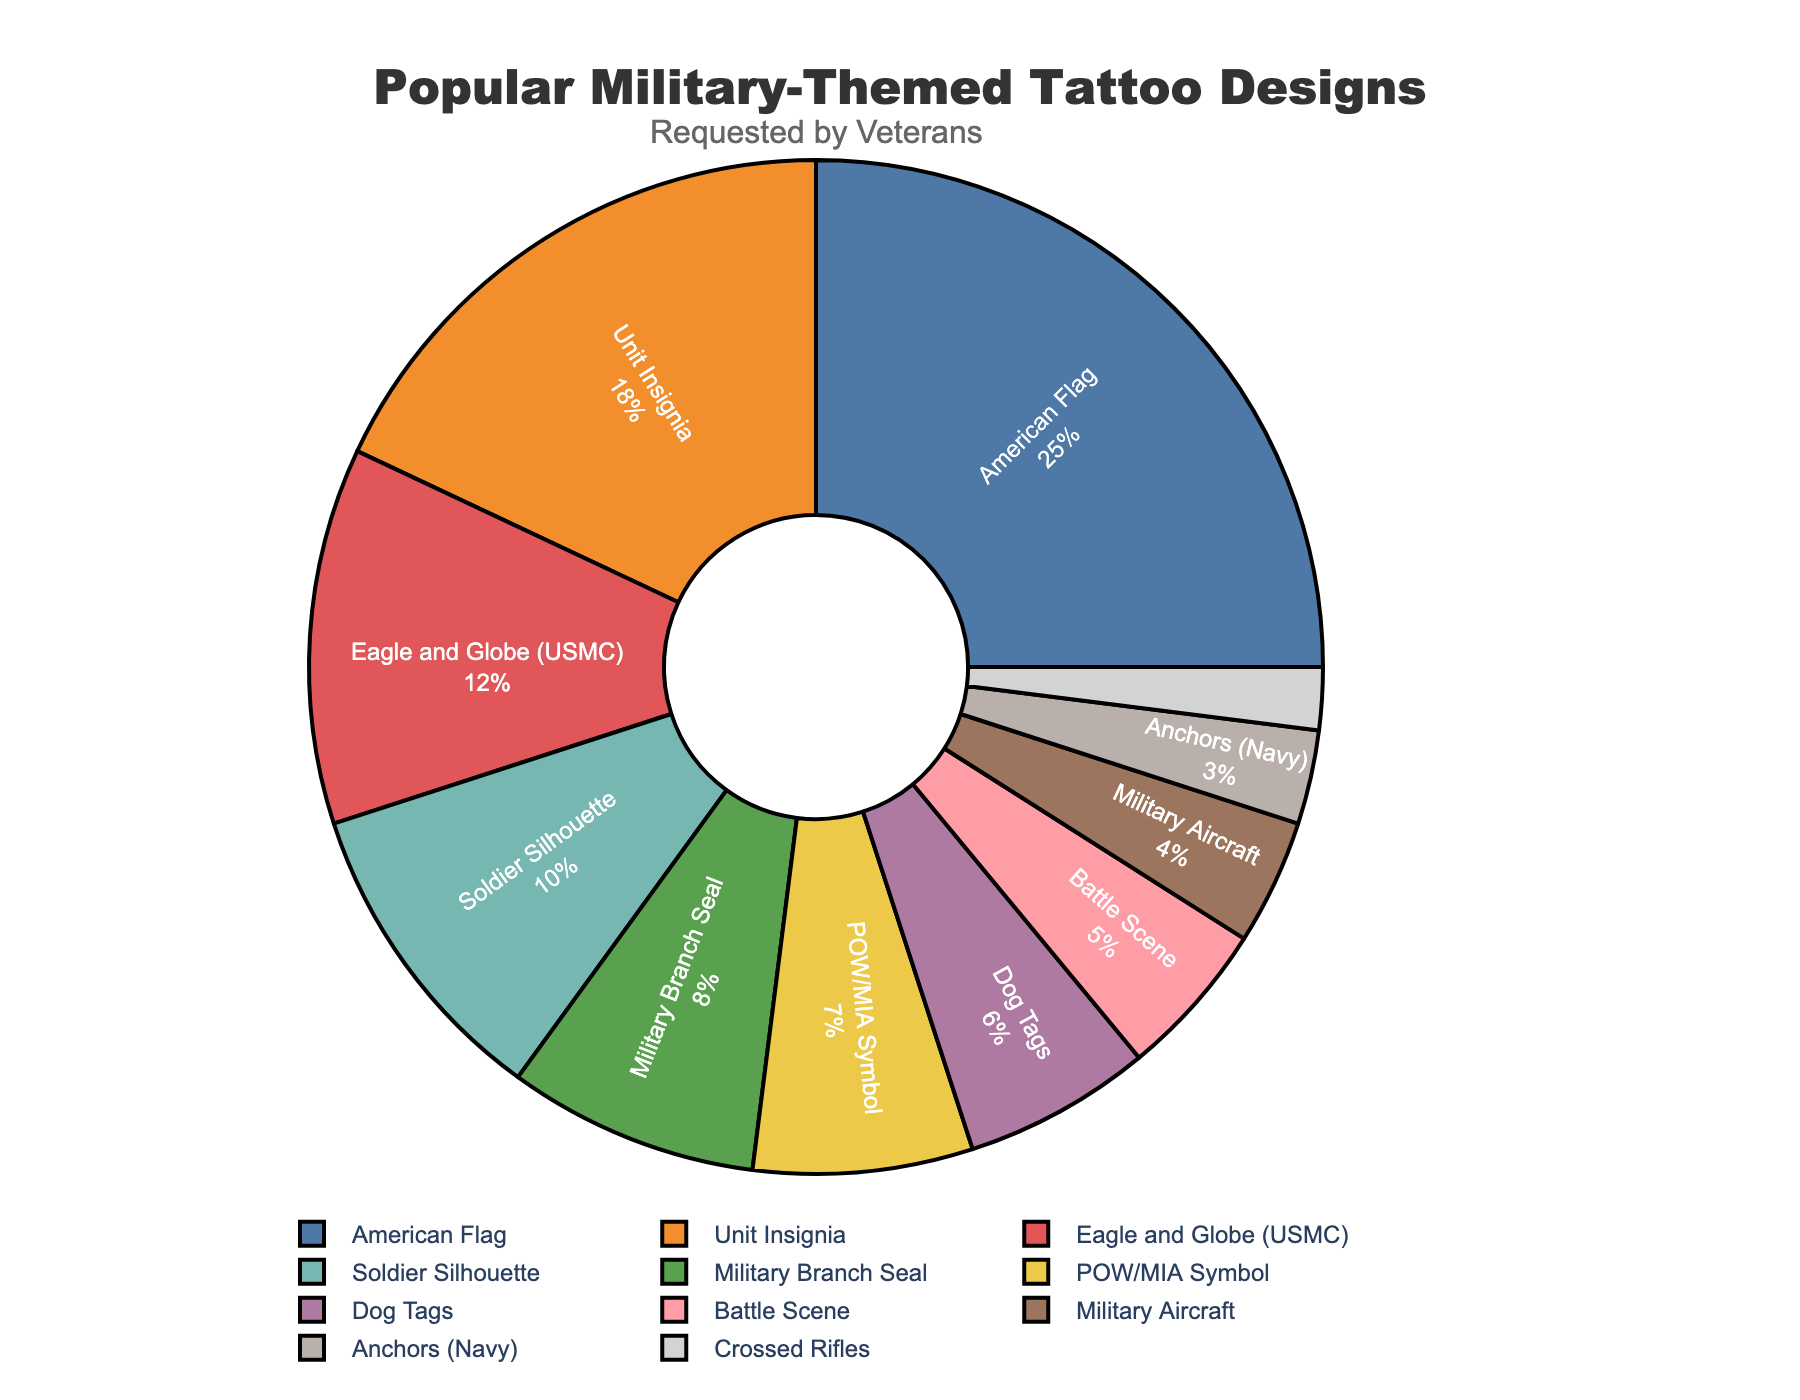What is the most popular military-themed tattoo design requested by veterans? To find the most popular design, look at the segment with the largest percentage in the pie chart. The "American Flag" segment occupies the largest portion, with 25%.
Answer: American Flag Which design is more requested, Military Branch Seal or Dog Tags? Compare the percentage values of the "Military Branch Seal" and "Dog Tags" segments. The Military Branch Seal has 8%, and Dog Tags have 6%, so Military Branch Seal is more requested.
Answer: Military Branch Seal What is the total percentage of designs related to branches of the military (Unit Insignia, Eagle and Globe (USMC), Military Branch Seal, Anchors (Navy), Crossed Rifles)? Sum the percentages for Unit Insignia (18%), Eagle and Globe (USMC) (12%), Military Branch Seal (8%), Anchors (Navy) (3%), and Crossed Rifles (2%): 18 + 12 + 8 + 3 + 2 = 43%.
Answer: 43% If you combine the percentages of Soldier Silhouette and POW/MIA Symbol designs, what percentage of the total do they make up? Add the percentages of Soldier Silhouette (10%) and POW/MIA Symbol (7%) to find the total: 10 + 7 = 17%.
Answer: 17% What portion of the pie chart does the Dog Tags design occupy visually based on its percentage? The Dog Tags design represents 6% of the pie chart. Visually, this would be a small segment of the pie chart, occupying 6% of the circular area.
Answer: 6% How does the request percentage of Battle Scene compare to Military Aircraft? Compare the proportion of Battle Scene (5%) with Military Aircraft (4%). Battle Scene has a slightly higher percentage than Military Aircraft.
Answer: Battle Scene What is the combined percentage of the three least popular designs? Identify the three designs with the smallest percentages: Crossed Rifles (2%), Anchors (Navy) (3%), and Military Aircraft (4%). Add these percentages: 2 + 3 + 4 = 9%.
Answer: 9% Among the designs with medium popularity (between 5% and 15%), which one has the lowest percentage? Focus on the range 5%-15% and identify the designs: POW/MIA Symbol (7%), Dog Tags (6%), Battle Scene (5%), Eagle and Globe (USMC) (12%), and Soldier Silhouette (10%). The Battle Scene has the lowest percentage in this range.
Answer: Battle Scene If the American Flag design's popularity increased by 5%, what would its new percentage be? Add 5% to the American Flag's current percentage of 25%: 25 + 5 = 30%.
Answer: 30% What is the ratio of the percentage of Unit Insignia to Military Branch Seal designs? Divide the percentage of Unit Insignia (18%) by the percentage of Military Branch Seal (8%): 18 / 8 = 2.25.
Answer: 2.25 